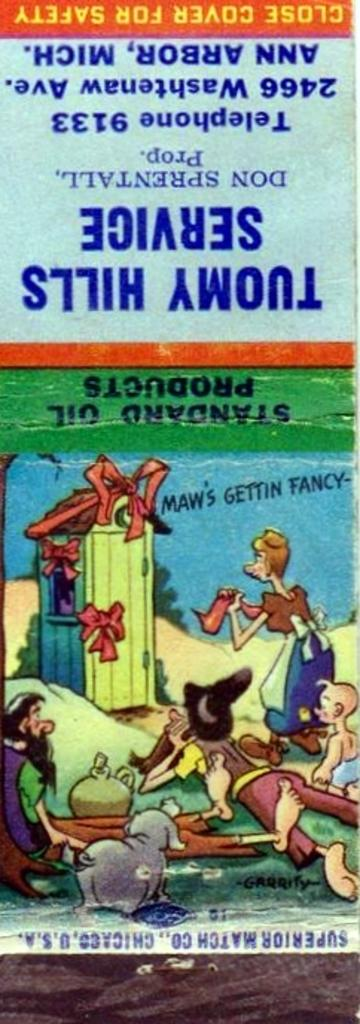Provide a one-sentence caption for the provided image. A matchbook from Tuomy Hills Service tells us to close the cover for safety. 